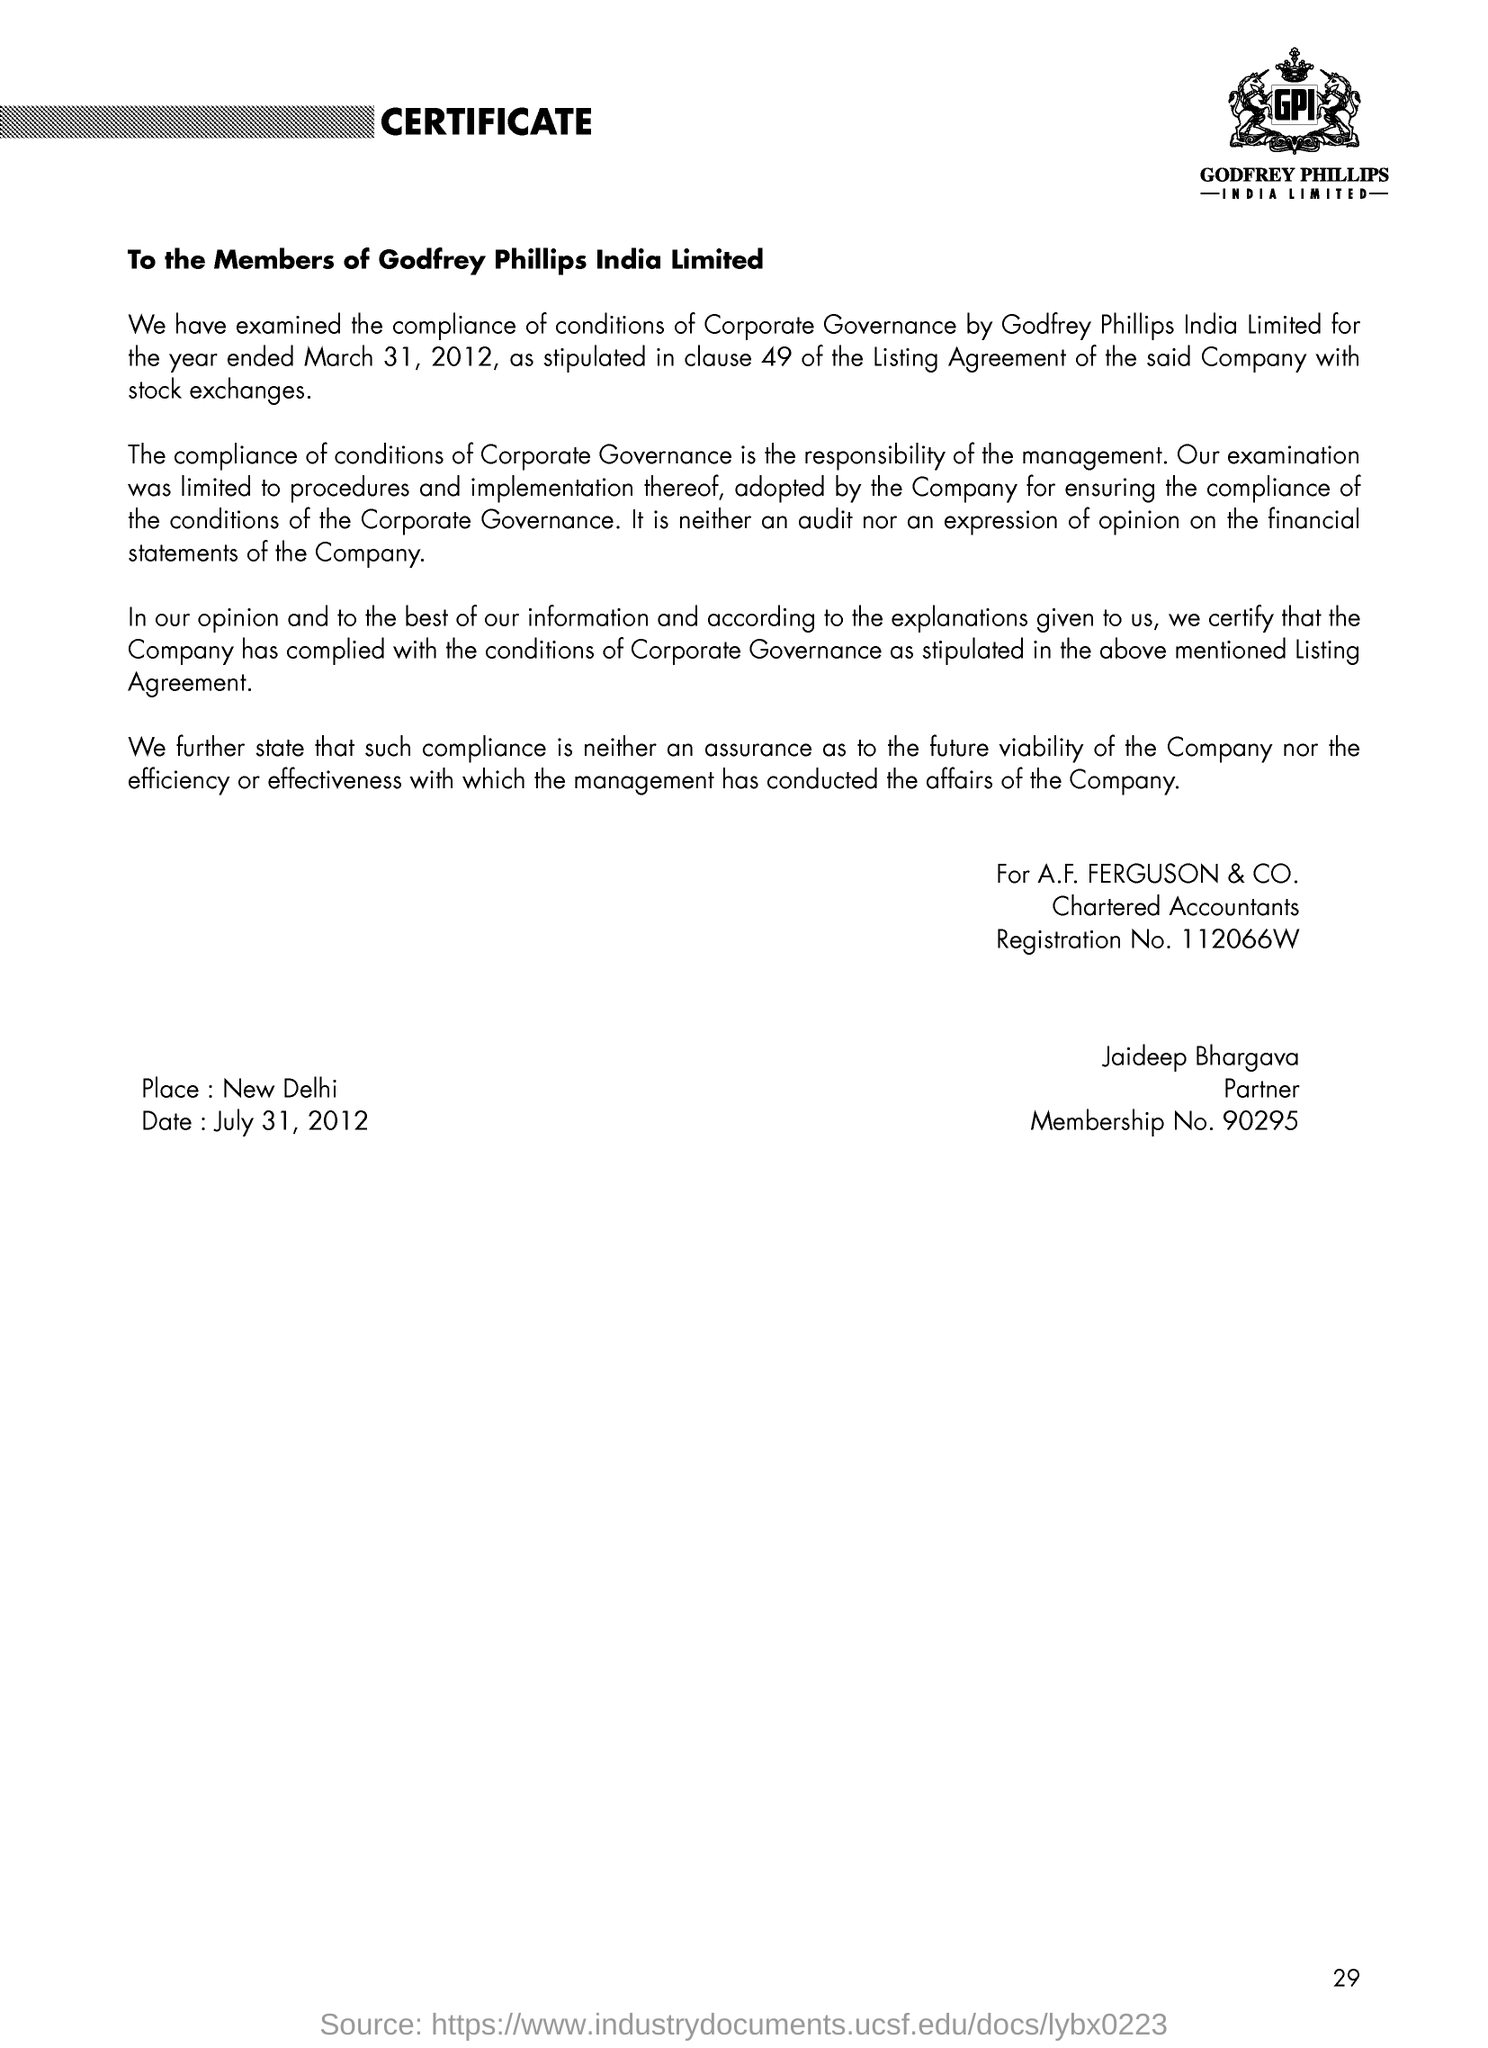Mention a couple of crucial points in this snapshot. The place mentioned is New Delhi. The membership number of Jaideep Bhargava is 90295 and so on. The letter is addressed to the members of Godfrey Phillips India Limited. The letter is dated July 31, 2012. The registration number of the Chartered Accountants is 112066W... 